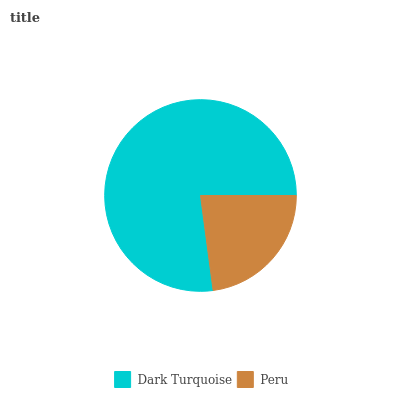Is Peru the minimum?
Answer yes or no. Yes. Is Dark Turquoise the maximum?
Answer yes or no. Yes. Is Peru the maximum?
Answer yes or no. No. Is Dark Turquoise greater than Peru?
Answer yes or no. Yes. Is Peru less than Dark Turquoise?
Answer yes or no. Yes. Is Peru greater than Dark Turquoise?
Answer yes or no. No. Is Dark Turquoise less than Peru?
Answer yes or no. No. Is Dark Turquoise the high median?
Answer yes or no. Yes. Is Peru the low median?
Answer yes or no. Yes. Is Peru the high median?
Answer yes or no. No. Is Dark Turquoise the low median?
Answer yes or no. No. 